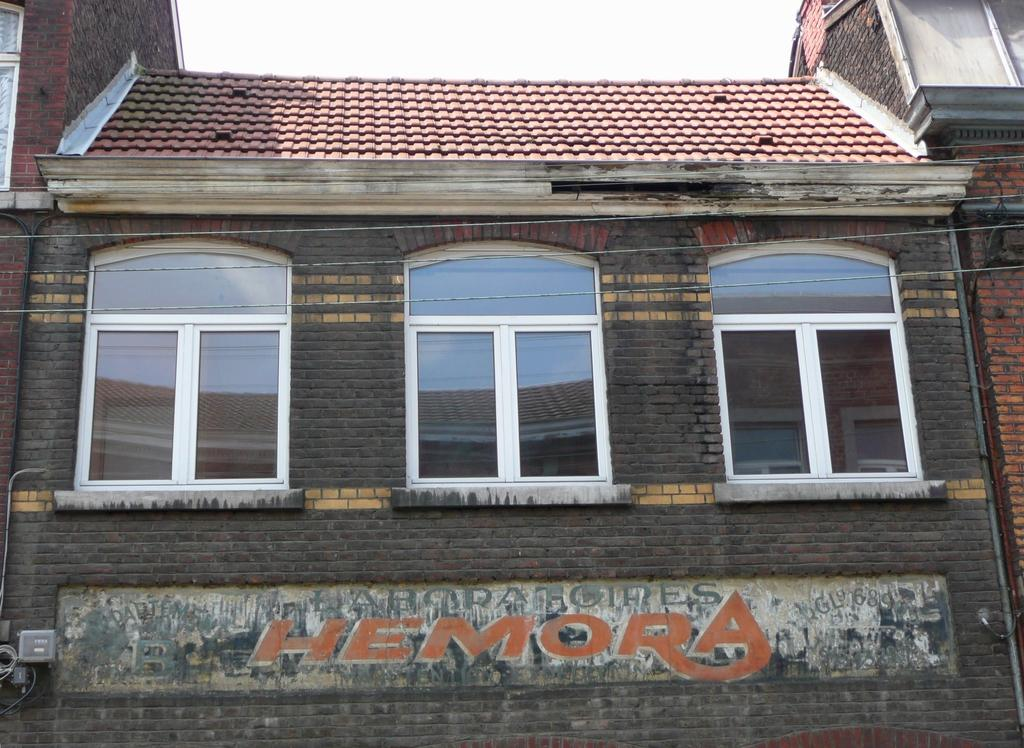What type of structure is present in the image? There is a building with windows in the image. What can be seen on the wall in the image? There is a wall with text and objects in the image. Are there any additional elements visible in the image? Yes, there are a few wires visible in the image. What is visible in the background of the image? The sky is visible in the image. How many deer can be seen running down the slope in the image? There are no deer or slopes present in the image. 